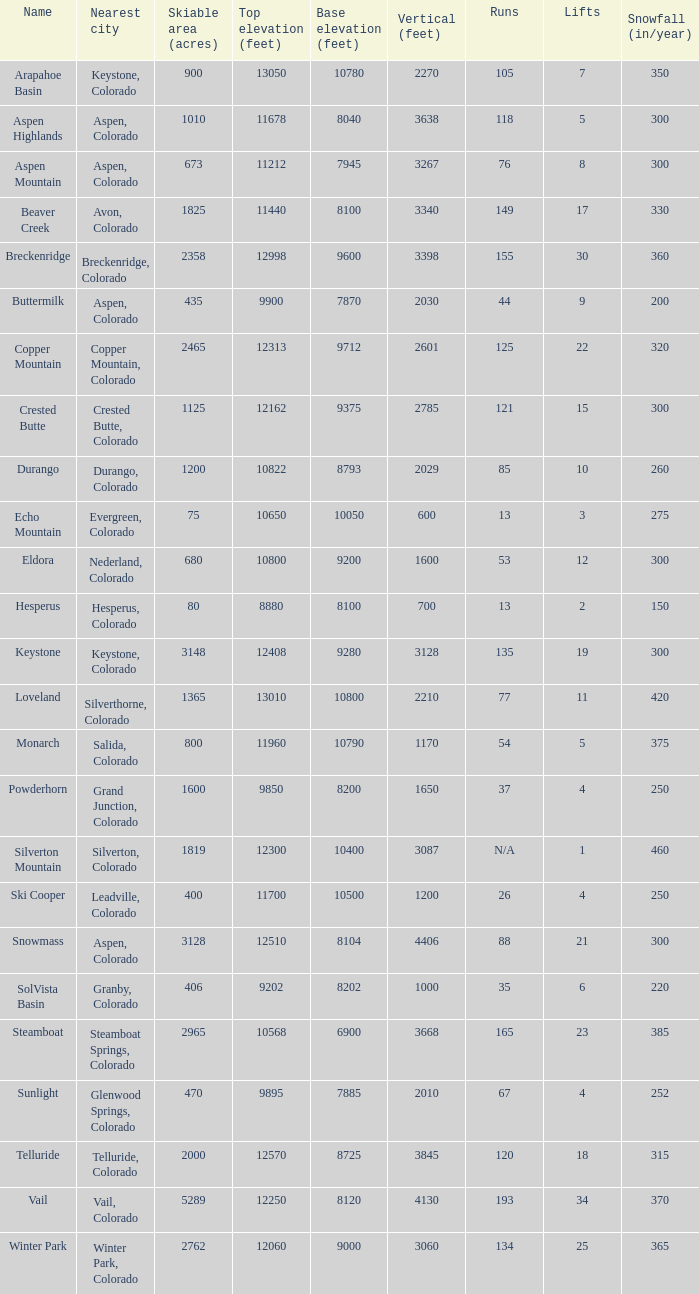If there are 11 elevators, what is the base altitude? 10800.0. 